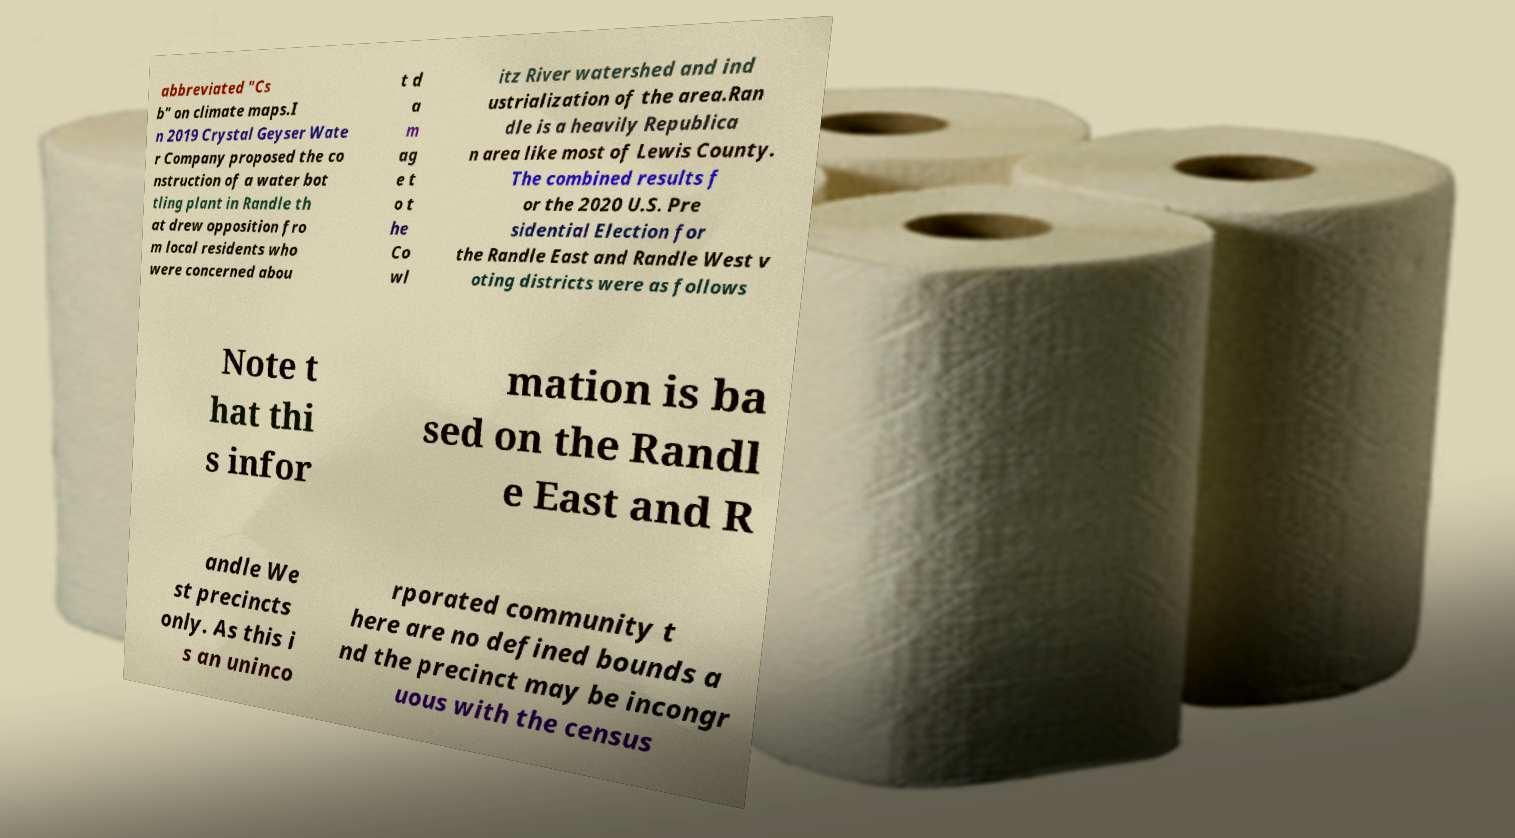Can you read and provide the text displayed in the image?This photo seems to have some interesting text. Can you extract and type it out for me? abbreviated "Cs b" on climate maps.I n 2019 Crystal Geyser Wate r Company proposed the co nstruction of a water bot tling plant in Randle th at drew opposition fro m local residents who were concerned abou t d a m ag e t o t he Co wl itz River watershed and ind ustrialization of the area.Ran dle is a heavily Republica n area like most of Lewis County. The combined results f or the 2020 U.S. Pre sidential Election for the Randle East and Randle West v oting districts were as follows Note t hat thi s infor mation is ba sed on the Randl e East and R andle We st precincts only. As this i s an uninco rporated community t here are no defined bounds a nd the precinct may be incongr uous with the census 